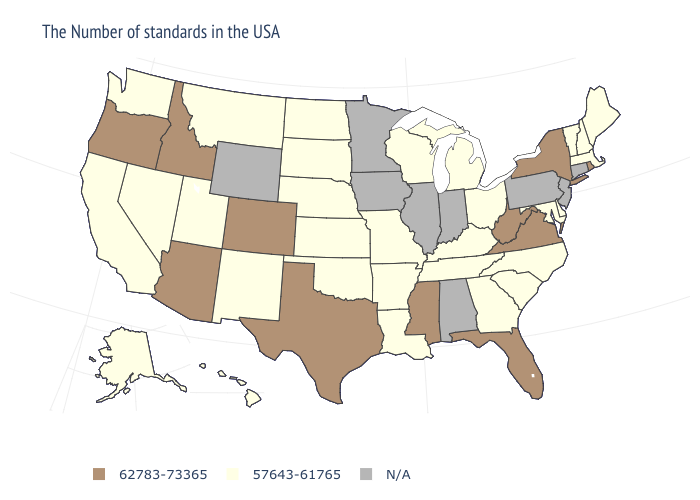Does Michigan have the highest value in the USA?
Answer briefly. No. Name the states that have a value in the range 62783-73365?
Be succinct. Rhode Island, New York, Virginia, West Virginia, Florida, Mississippi, Texas, Colorado, Arizona, Idaho, Oregon. Among the states that border Kansas , which have the highest value?
Keep it brief. Colorado. Name the states that have a value in the range 57643-61765?
Keep it brief. Maine, Massachusetts, New Hampshire, Vermont, Delaware, Maryland, North Carolina, South Carolina, Ohio, Georgia, Michigan, Kentucky, Tennessee, Wisconsin, Louisiana, Missouri, Arkansas, Kansas, Nebraska, Oklahoma, South Dakota, North Dakota, New Mexico, Utah, Montana, Nevada, California, Washington, Alaska, Hawaii. Name the states that have a value in the range N/A?
Concise answer only. Connecticut, New Jersey, Pennsylvania, Indiana, Alabama, Illinois, Minnesota, Iowa, Wyoming. What is the highest value in states that border Minnesota?
Give a very brief answer. 57643-61765. What is the highest value in states that border Minnesota?
Write a very short answer. 57643-61765. What is the value of North Dakota?
Short answer required. 57643-61765. Does West Virginia have the highest value in the USA?
Keep it brief. Yes. Name the states that have a value in the range 62783-73365?
Write a very short answer. Rhode Island, New York, Virginia, West Virginia, Florida, Mississippi, Texas, Colorado, Arizona, Idaho, Oregon. What is the lowest value in the USA?
Short answer required. 57643-61765. What is the value of California?
Keep it brief. 57643-61765. What is the lowest value in states that border Iowa?
Concise answer only. 57643-61765. What is the highest value in the Northeast ?
Be succinct. 62783-73365. 